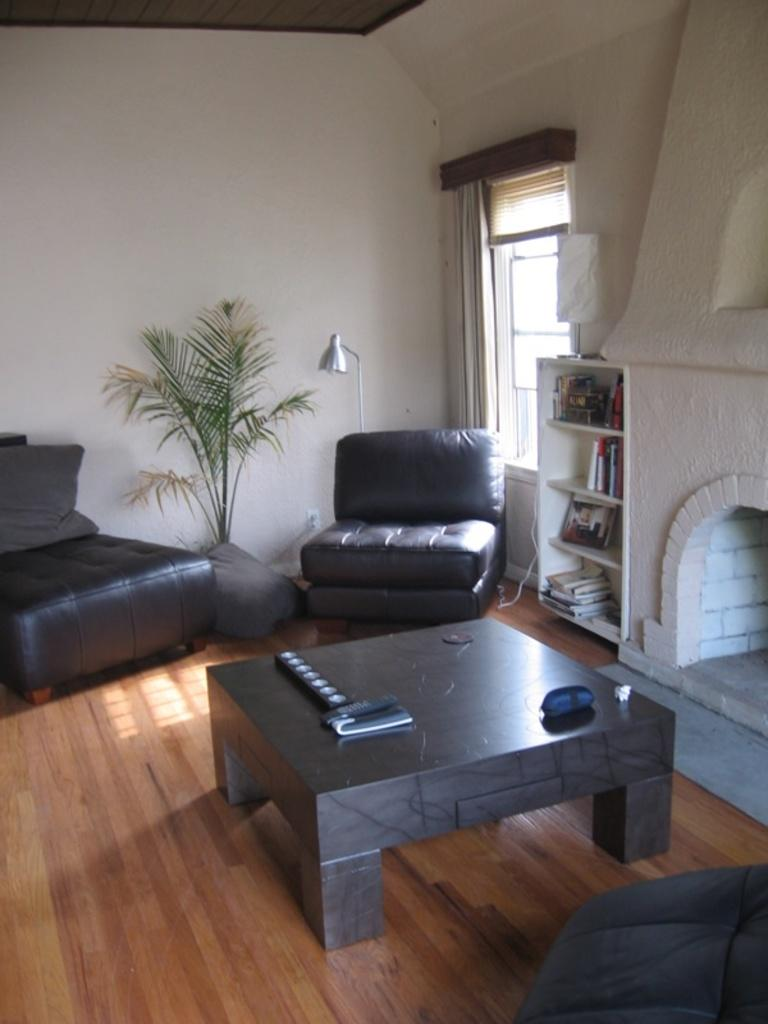What type of furniture can be seen in the image? There are chairs in the image. What type of soft furnishings are present in the image? There are pillows in the image. What is on the table in the image? There are objects on a table in the image. What type of heating appliance is present in the image? There is an electric fireplace in the image. What type of reading material is present in the image? There are books in racks in the image. What type of greenery is present in the image? There is a plant in the image. What type of opening is present in the image? There is a window in the image. What type of window treatment is present in the image? There is a curtain associated with the window. What type of architectural feature is present in the image? There is a wall in the image. What type of throne is present in the image? There is no throne present in the image. What type of design is featured on the wall in the image? The provided facts do not mention any specific design on the wall, only that there is a wall in the image. 